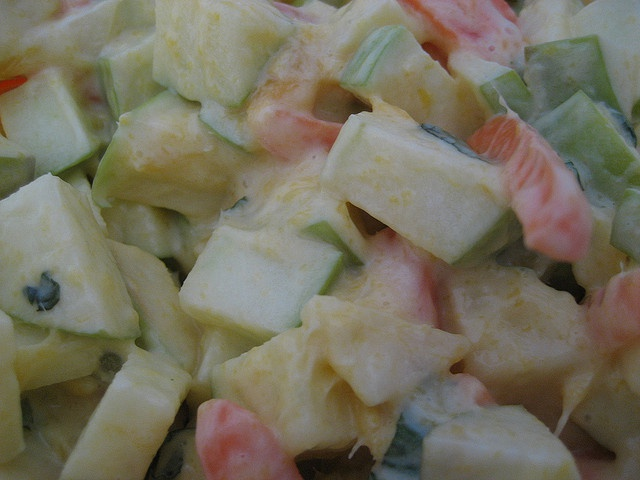Describe the objects in this image and their specific colors. I can see various objects in this image with different colors. 